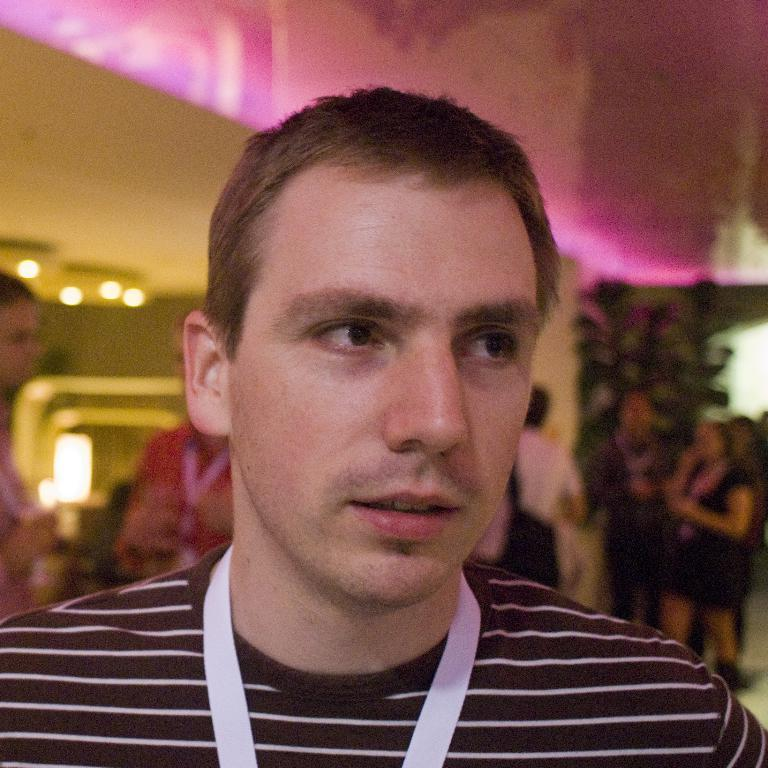How many people can be seen in the image? There are a few people in the image. What can be seen behind the people in the image? There is a background visible in the image. What is present in the background of the image? There are lights and objects in the background of the image. What type of pipe can be seen in the image? There is no pipe present in the image. How many eyes are visible on the people in the image? The number of eyes cannot be determined from the image alone, as it only shows a few people. 